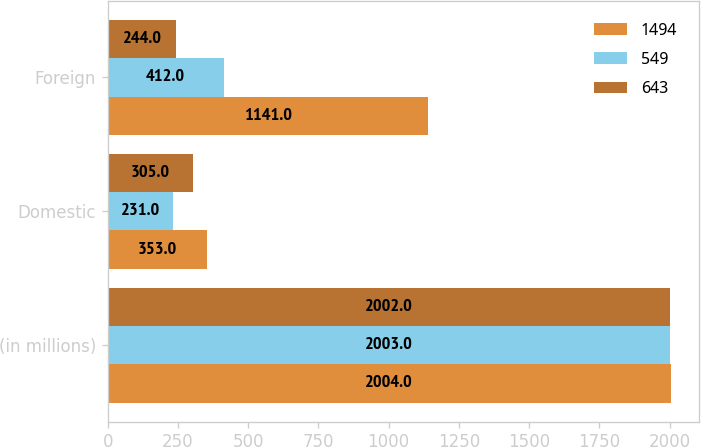Convert chart. <chart><loc_0><loc_0><loc_500><loc_500><stacked_bar_chart><ecel><fcel>(in millions)<fcel>Domestic<fcel>Foreign<nl><fcel>1494<fcel>2004<fcel>353<fcel>1141<nl><fcel>549<fcel>2003<fcel>231<fcel>412<nl><fcel>643<fcel>2002<fcel>305<fcel>244<nl></chart> 